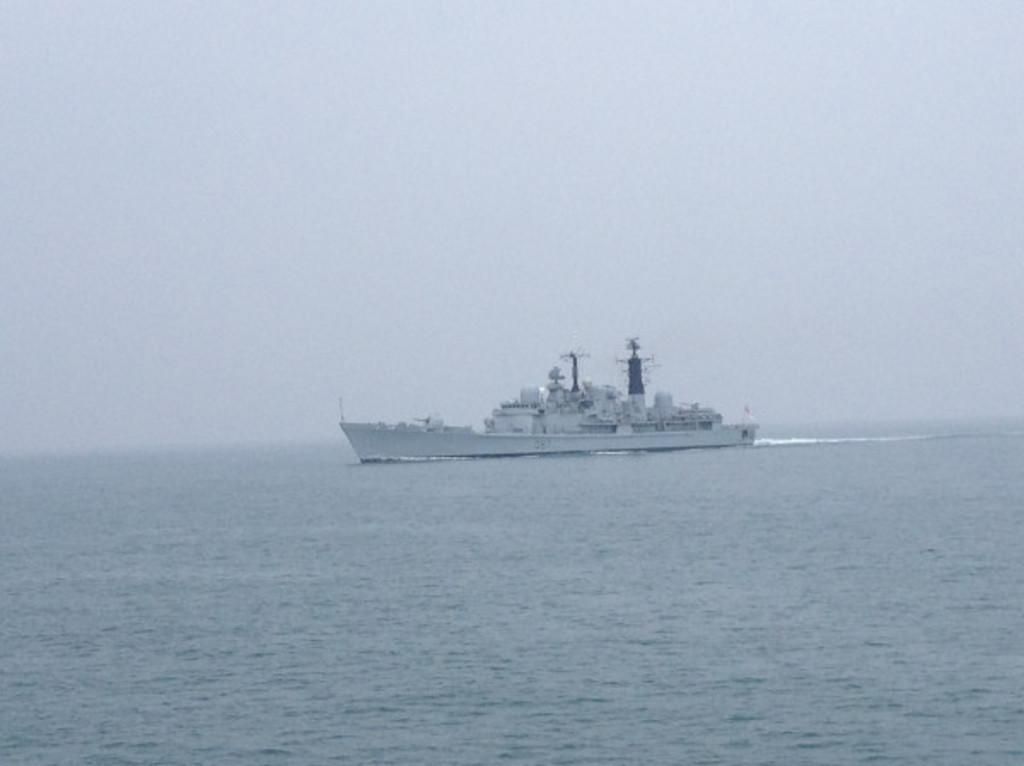What is the main subject of the image? There is a ship in the image. What is the ship doing in the image? The ship is sailing on the water. What else can be seen in the image besides the ship? The sky is visible in the image. What type of cushion is being used to steer the ship in the image? There is no cushion present in the image, and the ship does not require a cushion for steering. 